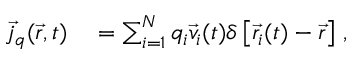Convert formula to latex. <formula><loc_0><loc_0><loc_500><loc_500>\begin{array} { r l } { \vec { j } _ { q } ( \vec { r } , t ) } & = \sum _ { i = 1 } ^ { N } q _ { i } \vec { v } _ { i } ( t ) \delta \left [ \vec { r } _ { i } ( t ) - \vec { r } \right ] \, , } \end{array}</formula> 